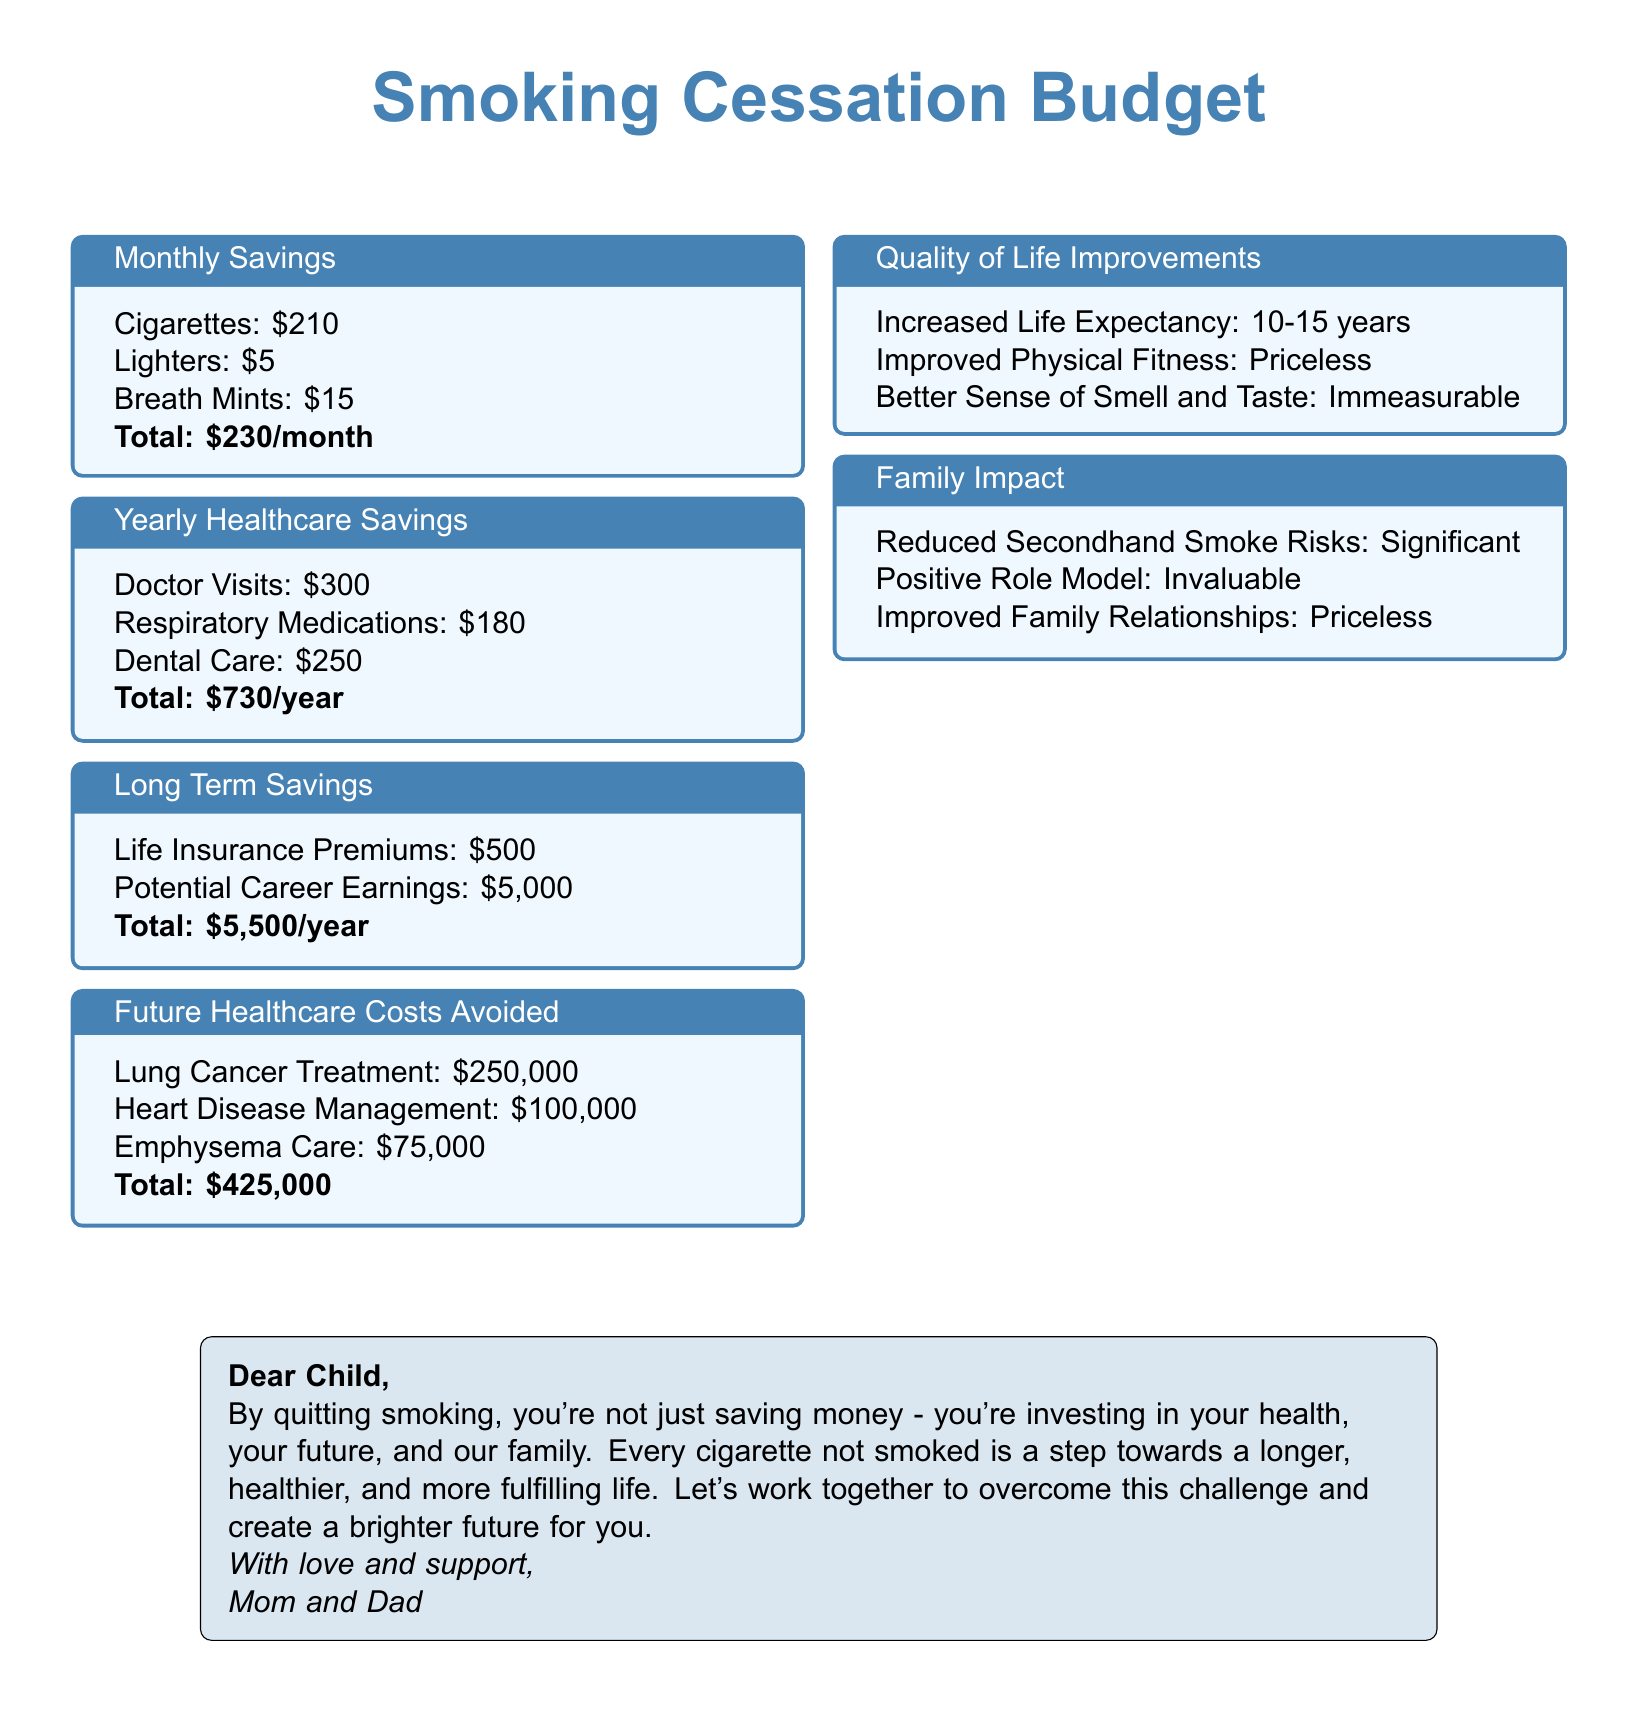what is the total monthly savings from quitting smoking? The total monthly savings comes from the sum of the costs associated with cigarettes, lighters, and breath mints, which is $210 + $5 + $15 = $230.
Answer: $230 what are the yearly healthcare savings from quitting smoking? The yearly healthcare savings include doctor visits, respiratory medications, and dental care, totaling $300 + $180 + $250 = $730.
Answer: $730 how much is the total future healthcare costs avoided by quitting smoking? The total future healthcare costs avoided include lung cancer treatment, heart disease management, and emphysema care, adding up to $250,000 + $100,000 + $75,000 = $425,000.
Answer: $425,000 what is the total long-term savings per year from quitting smoking? The long-term savings from quitting smoking comprise life insurance premiums and potential career earnings, which add up to $500 + $5,000 = $5,500.
Answer: $5,500 what improvement in life expectancy is noted from quitting smoking? The document states that quitting smoking increases life expectancy by 10-15 years.
Answer: 10-15 years what is listed as an invaluable family impact from quitting smoking? The document describes being a positive role model as an invaluable family impact.
Answer: Positive Role Model what is the total amount saved from lighters in the monthly savings? The document lists the cost of lighters as $5 in the monthly savings section.
Answer: $5 what is described as priceless in the quality of life improvements? The document mentions improved physical fitness as priceless in the quality of life improvements.
Answer: Improved Physical Fitness what significant risk reduction is mentioned in the family impact section? The document notes the reduced risks of secondhand smoke as significant in the family impact section.
Answer: Reduced Secondhand Smoke Risks 